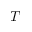<formula> <loc_0><loc_0><loc_500><loc_500>T</formula> 